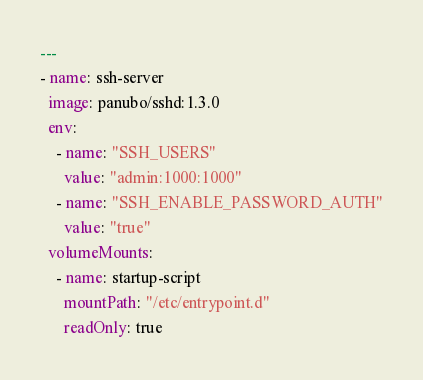Convert code to text. <code><loc_0><loc_0><loc_500><loc_500><_YAML_>---
- name: ssh-server
  image: panubo/sshd:1.3.0
  env:
    - name: "SSH_USERS"
      value: "admin:1000:1000"
    - name: "SSH_ENABLE_PASSWORD_AUTH"
      value: "true"
  volumeMounts:
    - name: startup-script
      mountPath: "/etc/entrypoint.d"
      readOnly: true
</code> 